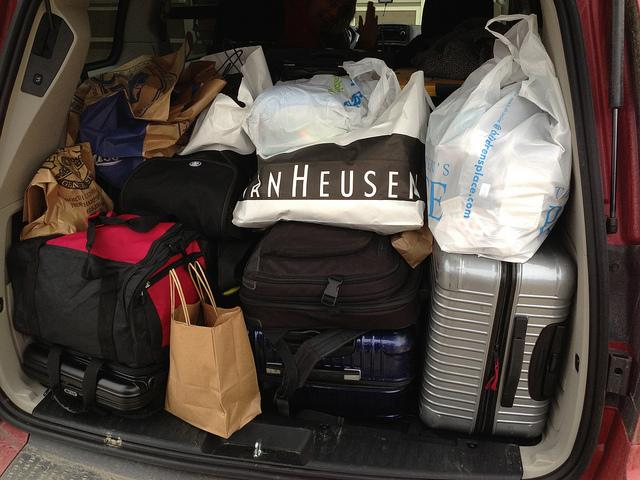What most likely happened before this?

Choices:
A) shopping
B) biking
C) swimming
D) hiking shopping 